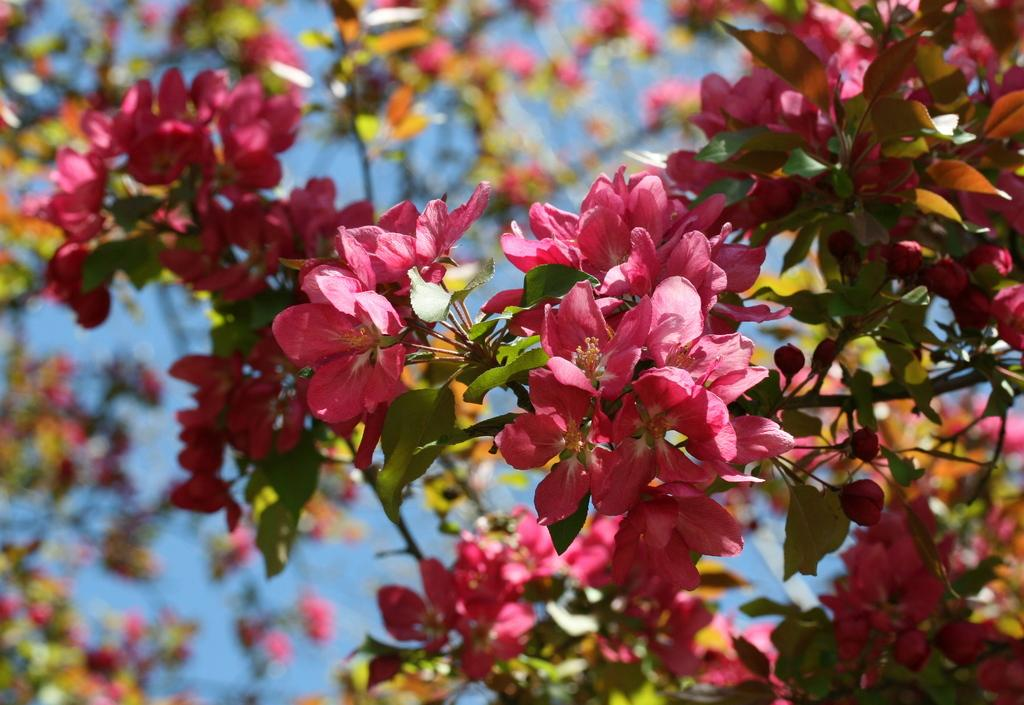What type of plant can be seen in the image? There is a tree in the image. What other natural elements are present in the image? There are flowers in the image. What color is the background of the image? The background of the image is blue in color. Can you see a jar filled with quicksand in the image? No, there is no jar or quicksand present in the image. What type of tool is being used to tighten a bolt in the image? There is no tool or bolt present in the image. 